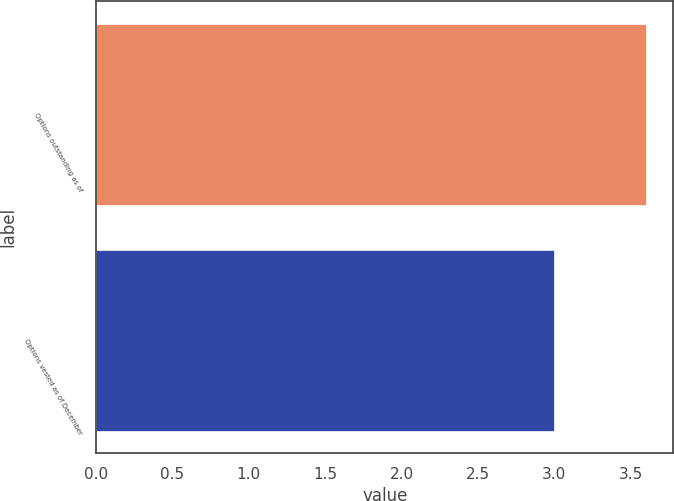Convert chart. <chart><loc_0><loc_0><loc_500><loc_500><bar_chart><fcel>Options outstanding as of<fcel>Options vested as of December<nl><fcel>3.6<fcel>3<nl></chart> 